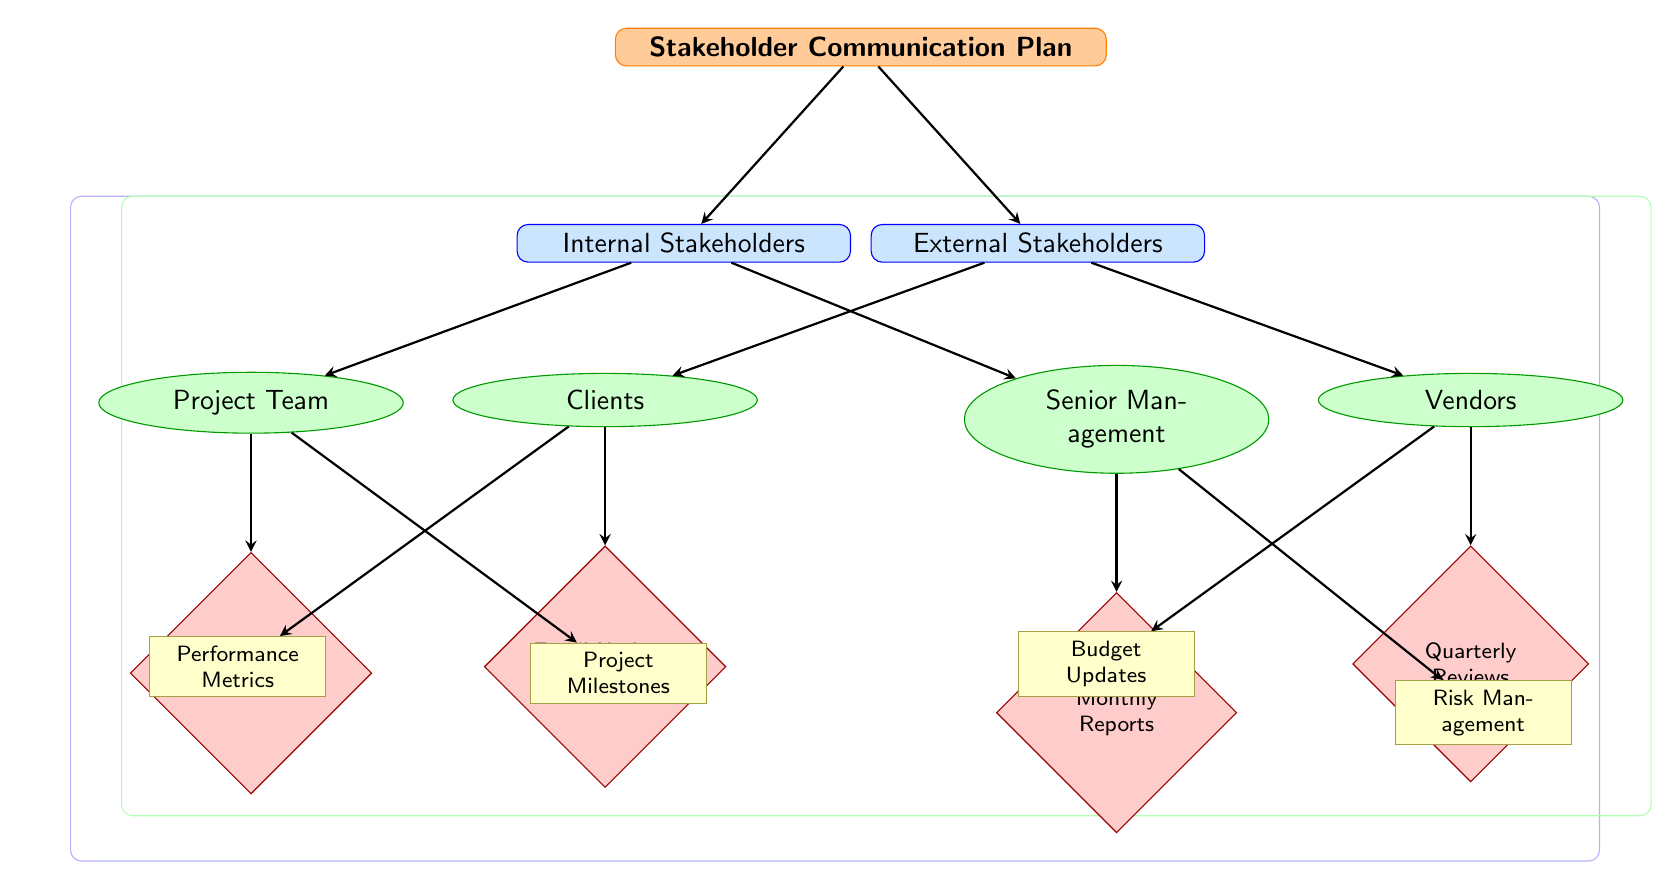What are the two main categories of stakeholders? The diagram presents two broad categories of stakeholders, which are depicted as separate nodes beneath the main root node. These categories are labeled "Internal Stakeholders" and "External Stakeholders."
Answer: Internal Stakeholders, External Stakeholders How many communication methods are listed for the Project Team? The diagram shows the "Project Team" node connected to one communication method node labeled "Meetings (Weekly)", indicating that there is only one specific communication method for this stakeholder group.
Answer: 1 What key message is associated with Senior Management? The key message is displayed in a node that connects to the "Senior Management" node. According to the diagram, the key message linked to Senior Management is "Risk Management."
Answer: Risk Management Which stakeholder group receives Email Updates? To find the answer, we refer to the "Email Updates (Bi-weekly)" node and trace it back to its connected stakeholder group node. This stakeholder group is identified as "Clients."
Answer: Clients How many total nodes are there in the diagram? To determine the total number of nodes, we count each unique node type, including the root, categories, groups, methods, and messages. There are 10 nodes in total: 1 root, 2 categories, 4 groups, 4 methods, and 4 messages, giving a total of 15.
Answer: 15 What is the frequency of the communication method for Vendors? The node connected to the "Vendors" stakeholder group indicates that the communication method is labeled "Quarterly Reviews," which specifies the frequency of communication used for this group.
Answer: Quarterly Which key message relates to Projects Milestones? Following the arrows from the "Meetings (Weekly)" method node, we locate the connected key message node that specifies "Project Milestones," directly answering the question regarding the key message associated with project milestones.
Answer: Project Milestones What color is used for the Internal Stakeholders category? To answer this question, we can refer back to the diagram where the category labeled "Internal Stakeholders" has a specified background color. According to the visualization, the color is a shade of blue.
Answer: Blue How many stakeholders are listed as Internal Stakeholders? The "Internal Stakeholders" node branches out to two additional nodes for "Project Team" and "Senior Management." Counting these stakeholder groups provides the total number of internal stakeholders in the diagram, which is two.
Answer: 2 